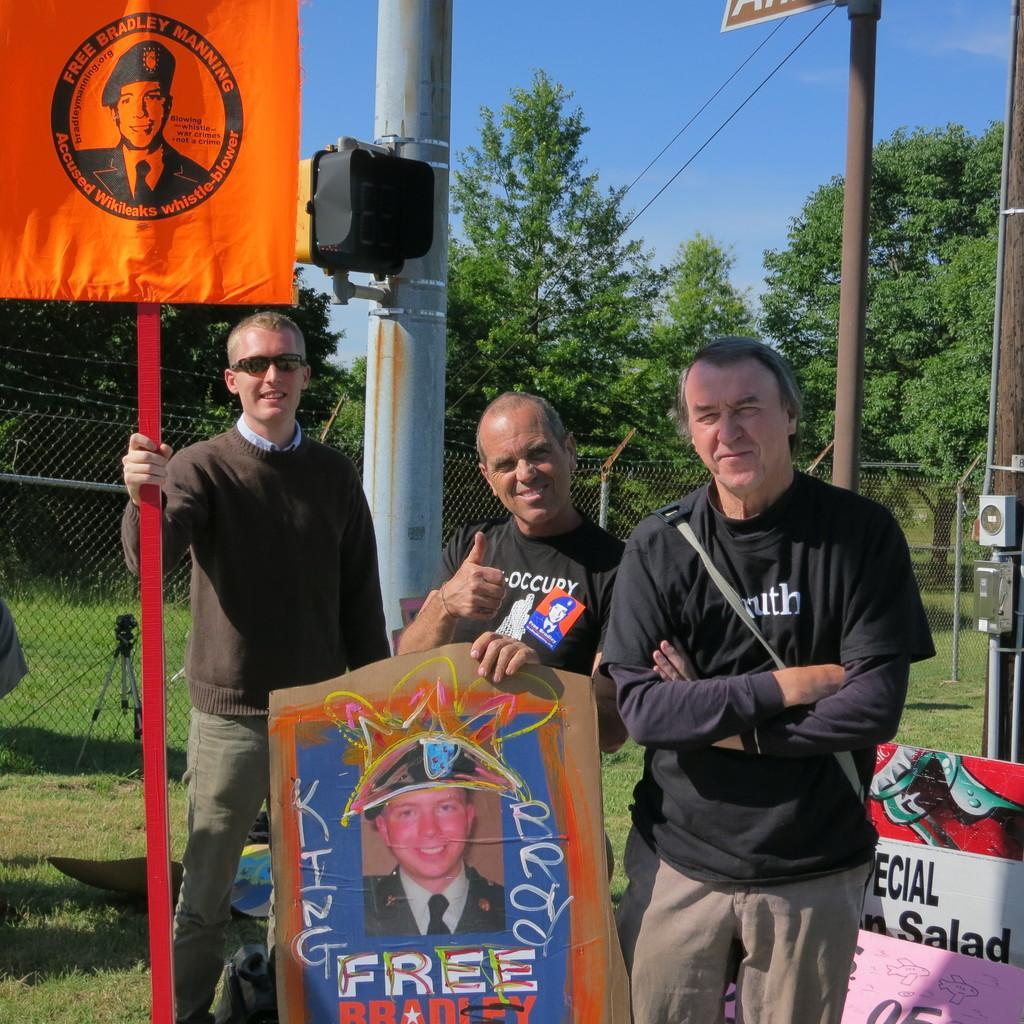Can you describe this image briefly? In this picture there are three old man wearing black t-shirts, standing in the front and giving a pose into the camera. In the front bottom side there is a photograph of the soldier and red color board. Behind there is a fencing grill and some trees. 